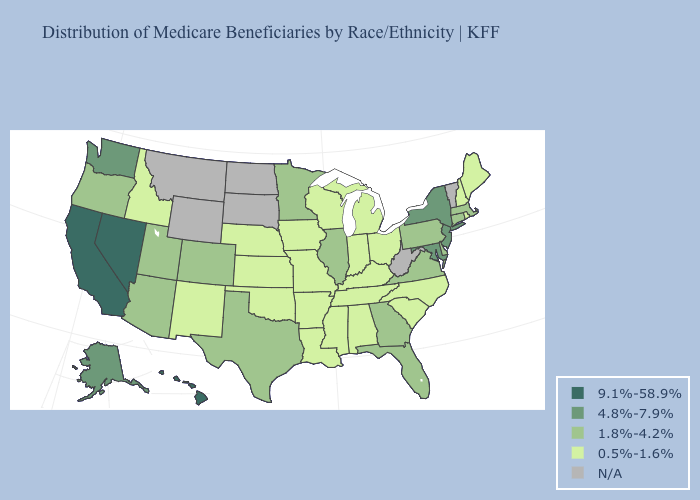Does Minnesota have the highest value in the MidWest?
Quick response, please. Yes. Does the map have missing data?
Give a very brief answer. Yes. What is the highest value in states that border Indiana?
Answer briefly. 1.8%-4.2%. What is the value of Delaware?
Short answer required. 1.8%-4.2%. What is the lowest value in the West?
Give a very brief answer. 0.5%-1.6%. Does Nevada have the highest value in the USA?
Short answer required. Yes. Does New Mexico have the lowest value in the USA?
Short answer required. Yes. What is the highest value in states that border Kansas?
Keep it brief. 1.8%-4.2%. Does North Carolina have the lowest value in the South?
Write a very short answer. Yes. What is the highest value in states that border Vermont?
Keep it brief. 4.8%-7.9%. What is the value of Ohio?
Keep it brief. 0.5%-1.6%. What is the highest value in the Northeast ?
Write a very short answer. 4.8%-7.9%. Among the states that border Illinois , which have the lowest value?
Concise answer only. Indiana, Iowa, Kentucky, Missouri, Wisconsin. Name the states that have a value in the range N/A?
Keep it brief. Montana, North Dakota, South Dakota, Vermont, West Virginia, Wyoming. 